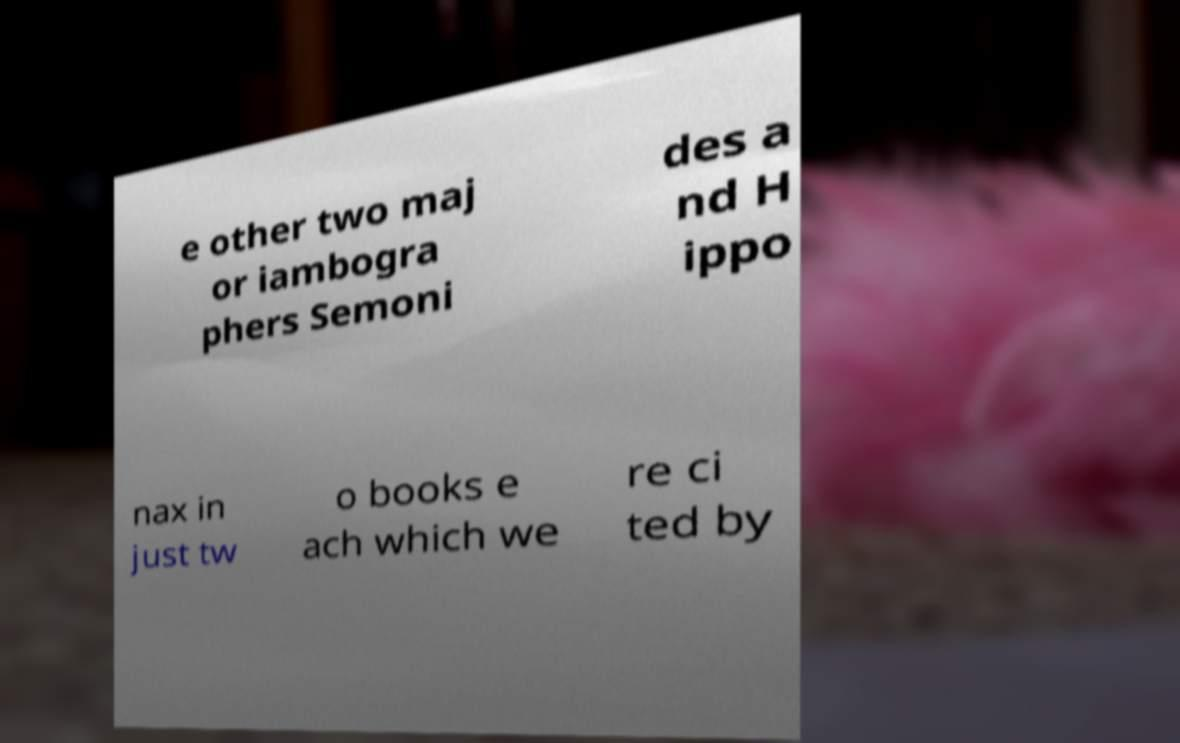There's text embedded in this image that I need extracted. Can you transcribe it verbatim? e other two maj or iambogra phers Semoni des a nd H ippo nax in just tw o books e ach which we re ci ted by 